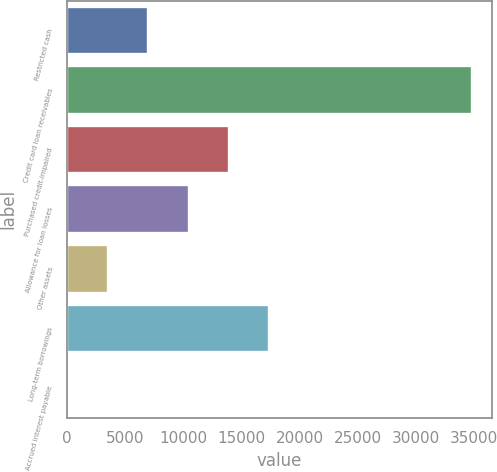Convert chart. <chart><loc_0><loc_0><loc_500><loc_500><bar_chart><fcel>Restricted cash<fcel>Credit card loan receivables<fcel>Purchased credit-impaired<fcel>Allowance for loan losses<fcel>Other assets<fcel>Long-term borrowings<fcel>Accrued interest payable<nl><fcel>6965.2<fcel>34782<fcel>13919.4<fcel>10442.3<fcel>3488.1<fcel>17396.5<fcel>11<nl></chart> 